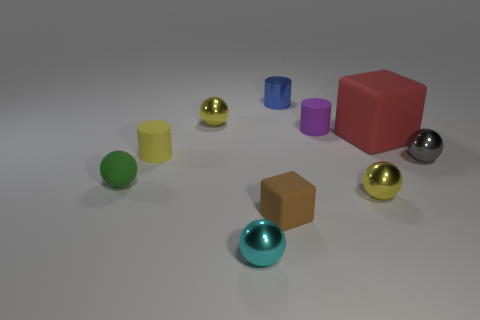Subtract all brown balls. Subtract all gray cylinders. How many balls are left? 5 Subtract all cubes. How many objects are left? 8 Add 9 big red blocks. How many big red blocks exist? 10 Subtract 0 gray cylinders. How many objects are left? 10 Subtract all yellow metal spheres. Subtract all blue metal objects. How many objects are left? 7 Add 6 tiny yellow balls. How many tiny yellow balls are left? 8 